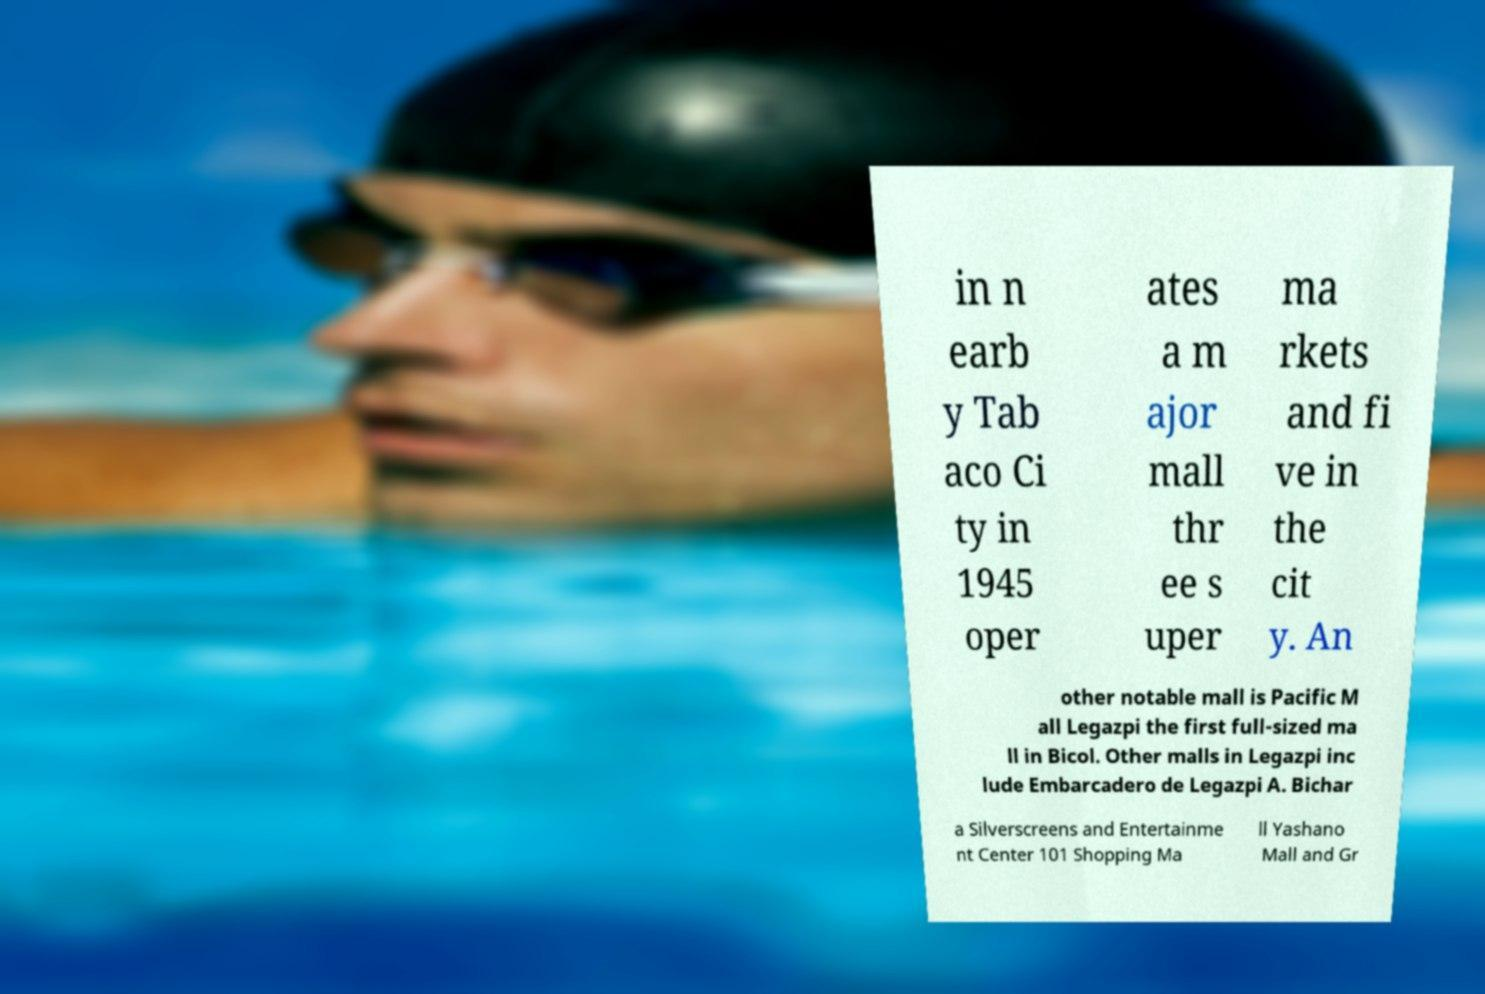Please read and relay the text visible in this image. What does it say? in n earb y Tab aco Ci ty in 1945 oper ates a m ajor mall thr ee s uper ma rkets and fi ve in the cit y. An other notable mall is Pacific M all Legazpi the first full-sized ma ll in Bicol. Other malls in Legazpi inc lude Embarcadero de Legazpi A. Bichar a Silverscreens and Entertainme nt Center 101 Shopping Ma ll Yashano Mall and Gr 